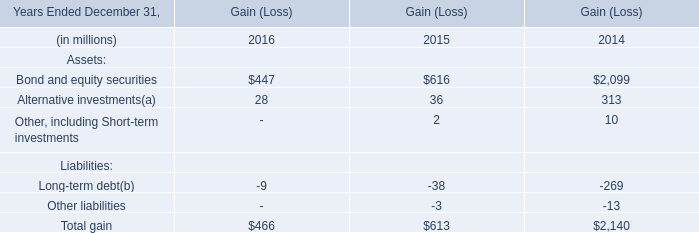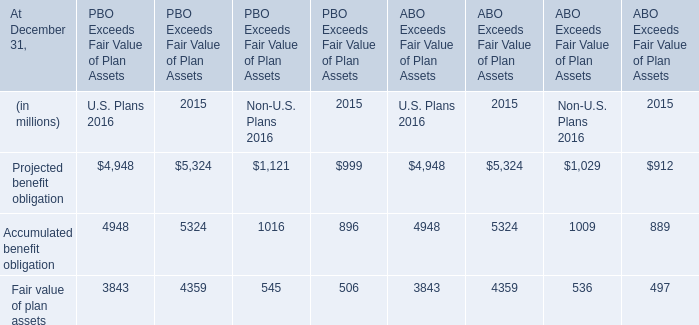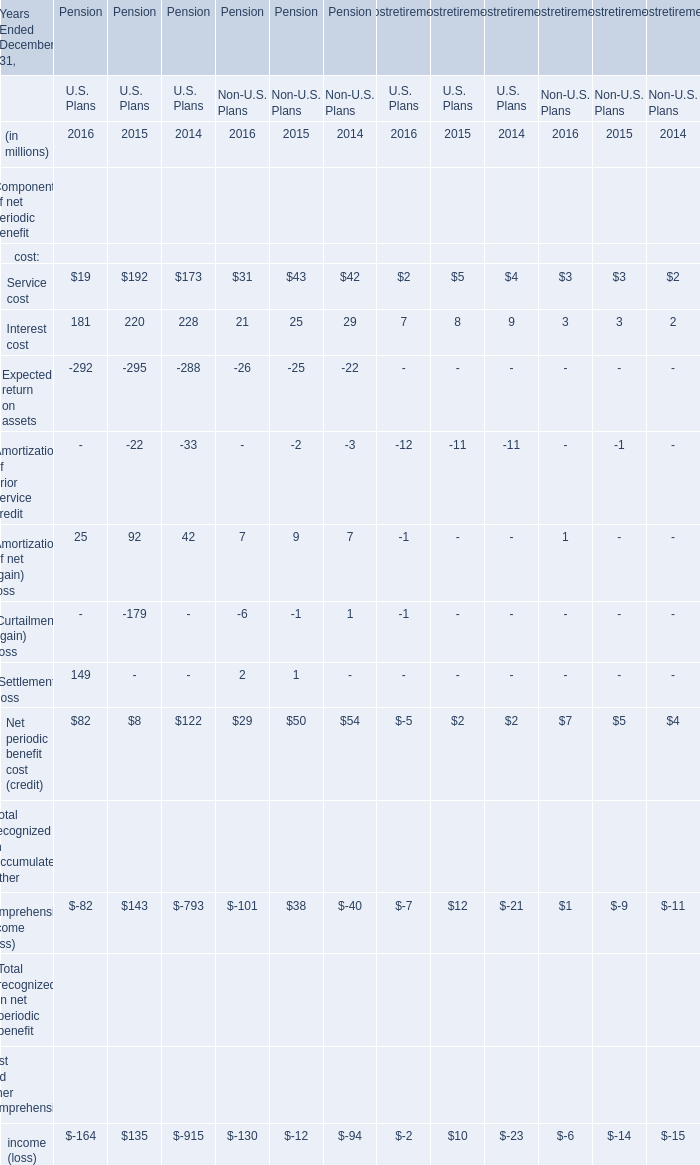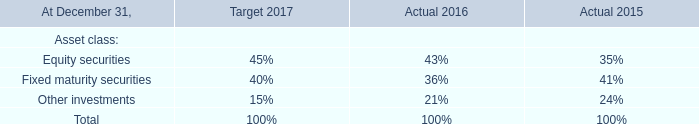In the year with lowest amount of Interest cost, what's the increasing rate of Service cost? 
Computations: (((((19 + 31) + 2) + 3) - (((192 + 43) + 5) + 3)) / (((192 + 43) + 5) + 3))
Answer: -0.77366. 